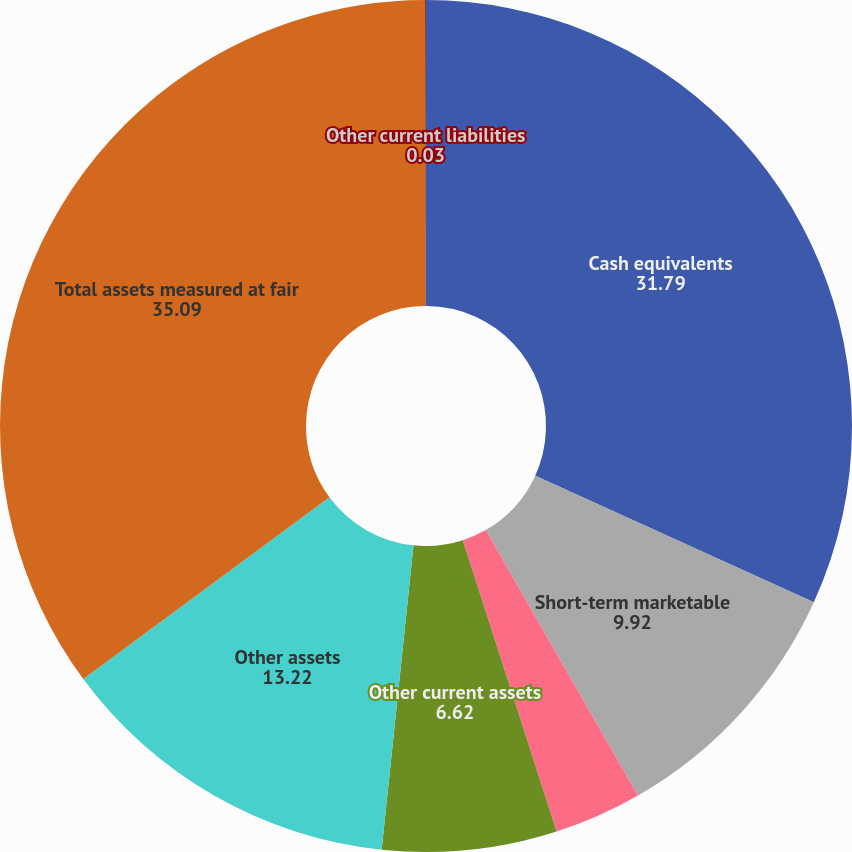Convert chart to OTSL. <chart><loc_0><loc_0><loc_500><loc_500><pie_chart><fcel>Cash equivalents<fcel>Short-term marketable<fcel>Long-term marketable<fcel>Other current assets<fcel>Other assets<fcel>Total assets measured at fair<fcel>Other current liabilities<nl><fcel>31.79%<fcel>9.92%<fcel>3.33%<fcel>6.62%<fcel>13.22%<fcel>35.09%<fcel>0.03%<nl></chart> 